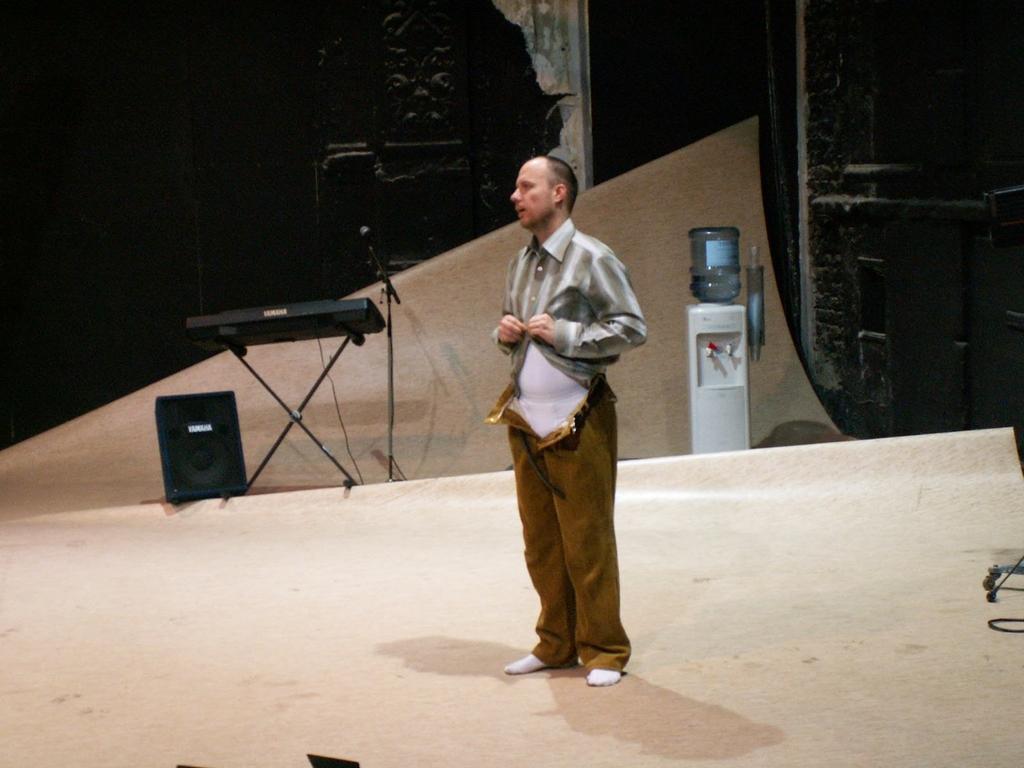Can you describe this image briefly? In this picture we can see a man, beside to him we can find a speaker, keyboard and a microphone, in the background we can see a bottle on the water filter. 